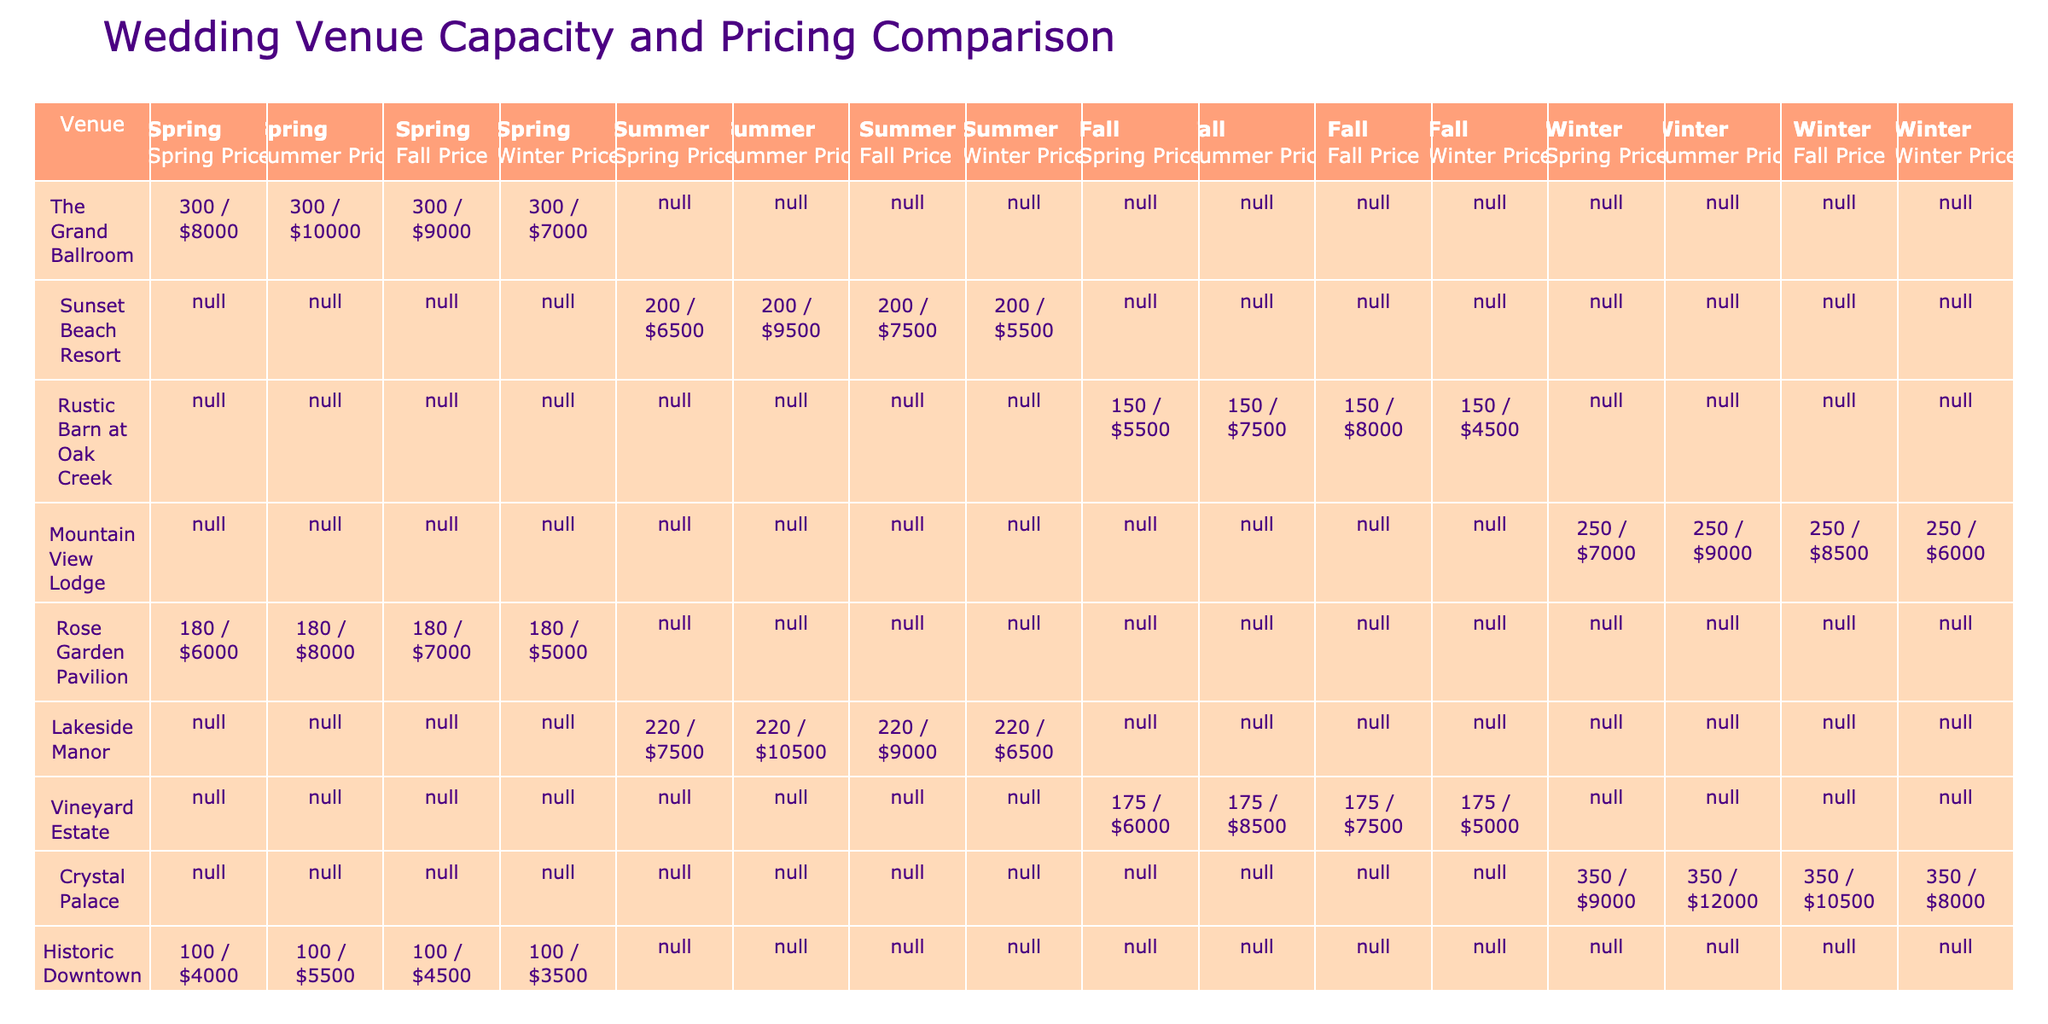What is the lowest Winter Price for a wedding venue? The table shows the Winter Prices for all venues. The prices are $7000 (The Grand Ballroom), $5500 (Sunset Beach Resort), $6000 (Mountain View Lodge), $8000 (Rustic Barn at Oak Creek), $5000 (Crystal Palace), and $4500 (Vineyard Estate). Hence, the lowest price is found at Vineyard Estate, which is $4500.
Answer: $4500 Which wedding venue has the highest capacity? Reviewing the table, the capacities are listed as 300 (The Grand Ballroom), 200 (Sunset Beach Resort), 150 (Rustic Barn at Oak Creek), 250 (Mountain View Lodge), 180 (Rose Garden Pavilion), 220 (Lakeside Manor), 175 (Vineyard Estate), 100 (Historic Downtown Chapel), and 280 (Tropical Island Resort). The highest capacity is 300 at The Grand Ballroom.
Answer: The Grand Ballroom Calculate the average Spring Price across all venues. The Spring Prices for venues are $8000, $6500, $5500, $7000, $6000, $7500, $6000, $9000, and $4000. First, sum these values: $8000 + $6500 + $5500 + $7000 + $6000 + $7500 + $6000 + $9000 + $4000 = $60500. Then, divide by the number of venues (9): $60500 / 9 = $6722.22. Therefore, the average Spring Price is approximately $6722.22.
Answer: $6722.22 Is the Summer Price for the Rustic Barn at Oak Creek lower than for the Rose Garden Pavilion? The Summer Price for Rustic Barn at Oak Creek is $7500, and for Rose Garden Pavilion, it is $8000. Since $7500 is less than $8000, the statement is true.
Answer: Yes What is the difference between the highest and lowest Fall Prices? First, check the Fall Prices: $9000 (The Grand Ballroom), $7500 (Sunset Beach Resort), $8000 (Mountain View Lodge), $4500 (Rustic Barn at Oak Creek), $7500 (Vineyard Estate), and $7000 (Rose Garden Pavilion). The highest is $9000 and the lowest is $4500. The difference is $9000 - $4500 = $4500. Therefore, the difference between the highest and lowest Fall Prices is $4500.
Answer: $4500 How many venues have a capacity greater than 200? The table lists the capacities: 300 (The Grand Ballroom), 200 (Sunset Beach Resort), 150 (Rustic Barn at Oak Creek), 250 (Mountain View Lodge), 180 (Rose Garden Pavilion), and 220 (Lakeside Manor), 175 (Vineyard Estate), 100 (Historic Downtown Chapel), and 280 (Tropical Island Resort). The only venues with a capacity greater than 200 are The Grand Ballroom, Mountain View Lodge, Lakeside Manor, and Tropical Island Resort, totaling four venues.
Answer: 4 Compare the Summer Prices for Sunset Beach Resort and Tropical Island Resort. The Summer Price for Sunset Beach Resort is $9500 while for Tropical Island Resort it is $12500. Since $9500 is less than $12500, Sunset Beach Resort has a lower Summer Price compared to Tropical Island Resort.
Answer: Sunset Beach Resort What season do you get the highest combined price for the Rustic Barn at Oak Creek? The prices for Rustic Barn at Oak Creek across the seasons are $9000 (Spring), $7500 (Summer), $8000 (Fall), and $4500 (Winter). Therefore, add these to determine the highest: $9000 + $7500 + $8000 + $4500 = $29000. This price occurs in Spring since it contributes the highest value among all season prices.
Answer: Spring Which venue has the same Spring and Winter Price? Check the Spring and Winter Prices: The Spring Price is $8000 (The Grand Ballroom), $6500 (Sunset Beach Resort), $5500 (Rustic Barn at Oak Creek), $7000 (Mountain View Lodge), $6000 (Rose Garden Pavilion), $7500 (Lakeside Manor), $6000 (Vineyard Estate), $4000 (Historic Downtown Chapel), and $8500 (Crystal Palace) in Spring. In Winter, the prices are $7000 (The Grand Ballroom), $5500 (Sunset Beach Resort), $6000 (Mountain View Lodge), $8000 (Rustic Barn at Oak Creek), $5000 (Rose Garden Pavilion), $6500 (Lakeside Manor), $8000 (Vineyard Estate), $3500 (Historic Downtown Chapel), and $8000 (Crystal Palace). Only Rosa Garden Pavilion has the same price of $6000 in both seasons.
Answer: Rose Garden Pavilion 